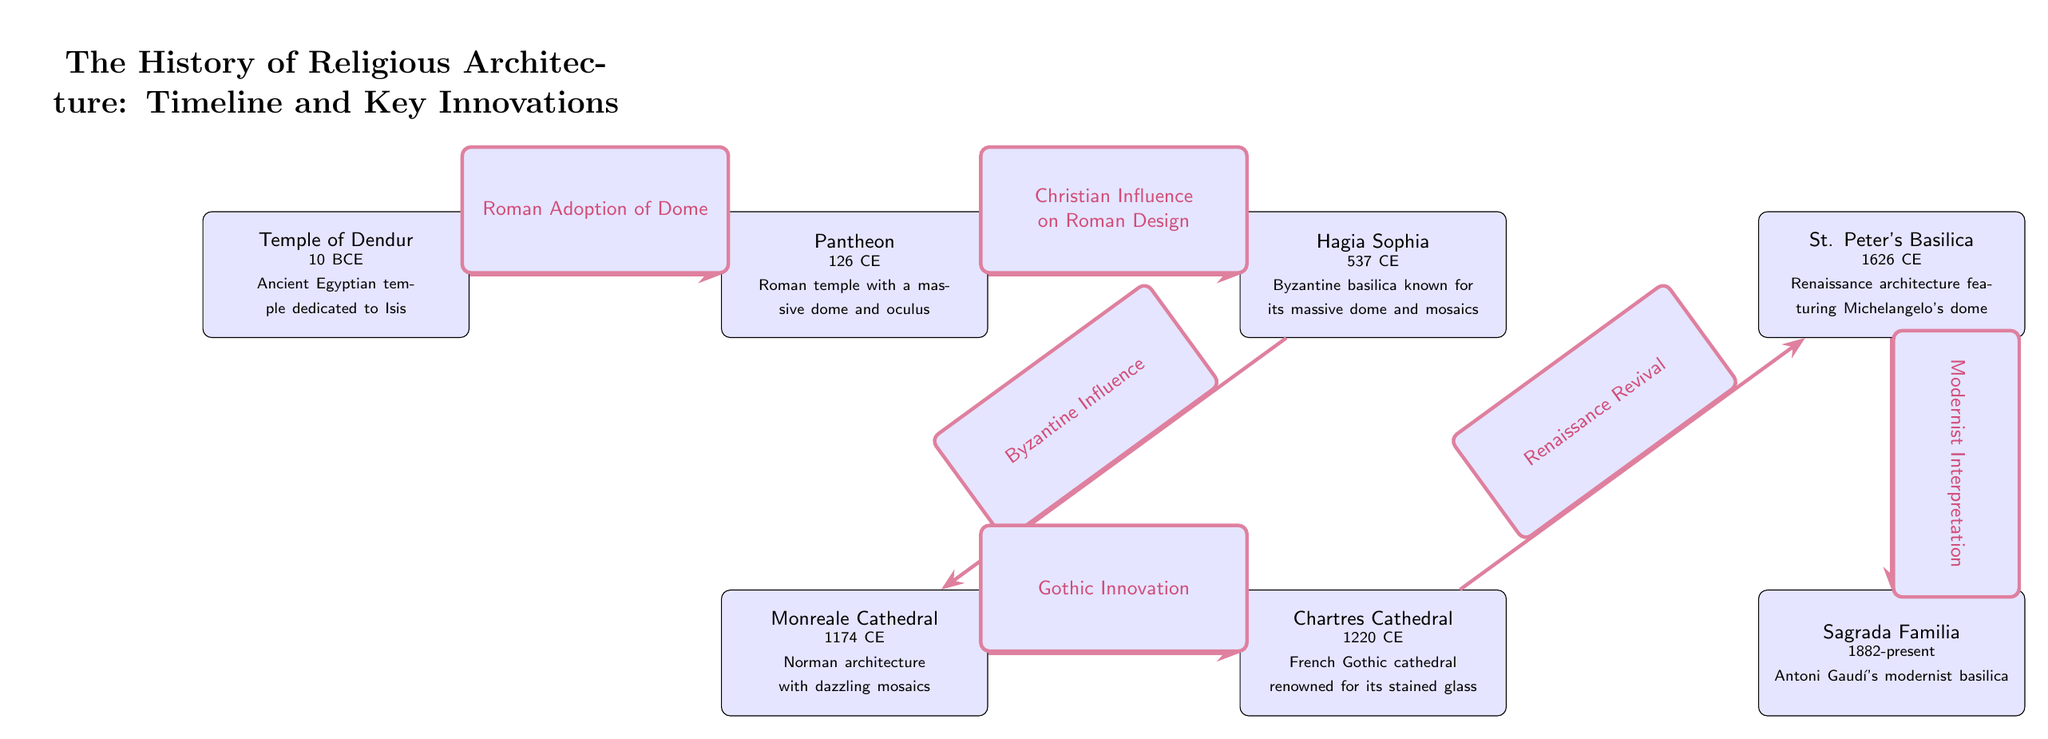What is the earliest religious architecture mentioned in the diagram? The diagram lists the Temple of Dendur as the earliest architecture, which dates back to 10 BCE.
Answer: Temple of Dendur How many religious architectures are represented in the diagram? By counting each node, we find there are a total of 6 architectural representations: Temple of Dendur, Pantheon, Hagia Sophia, Monreale Cathedral, Chartres Cathedral, and St. Peter's Basilica.
Answer: 6 What innovation connects the Pantheon and Hagia Sophia? The relationship between the Pantheon and Hagia Sophia is defined by the label 'Christian Influence on Roman Design,' which indicates the influence that the Pantheon had on later Christian structures, particularly in the design of the Hagia Sophia.
Answer: Christian Influence on Roman Design Which cathedral is known for its stained glass? The diagram notes that Chartres Cathedral is renowned for its stained glass, making it clear that this feature is distinctive of that structure.
Answer: Chartres Cathedral What notable architectural feature is associated with St. Peter's Basilica? The label associated with St. Peter's Basilica points to its distinguished Renaissance architecture, specifically highlighting Michelangelo's dome as a key feature of the structure.
Answer: Michelangelo's dome How does the timeline advance from Monreale Cathedral to Chartres Cathedral? The connection from Monreale Cathedral to Chartres Cathedral is marked by the label 'Gothic Innovation,' indicating that developments in Gothic architecture served as a bridge between these two architectural styles.
Answer: Gothic Innovation What period does the construction of Sagrada Familia span? The diagram shows that construction of the Sagrada Familia began in 1882 and is ongoing, as indicated by the "present" label.
Answer: 1882-present Which architectural style is most recently represented on the diagram? The Sagrada Familia, currently under construction since 1882, is the latest architectural representation in the timeline, indicating that it reflects modernist interpretations of religious architecture.
Answer: Modernist Interpretation Who designed the Sagrada Familia? By analyzing the information provided in the Sagrada Familia node, we see that it is attributed to Antoni Gaudí, who is known for his modernist approach to religious architecture.
Answer: Antoni Gaudí 